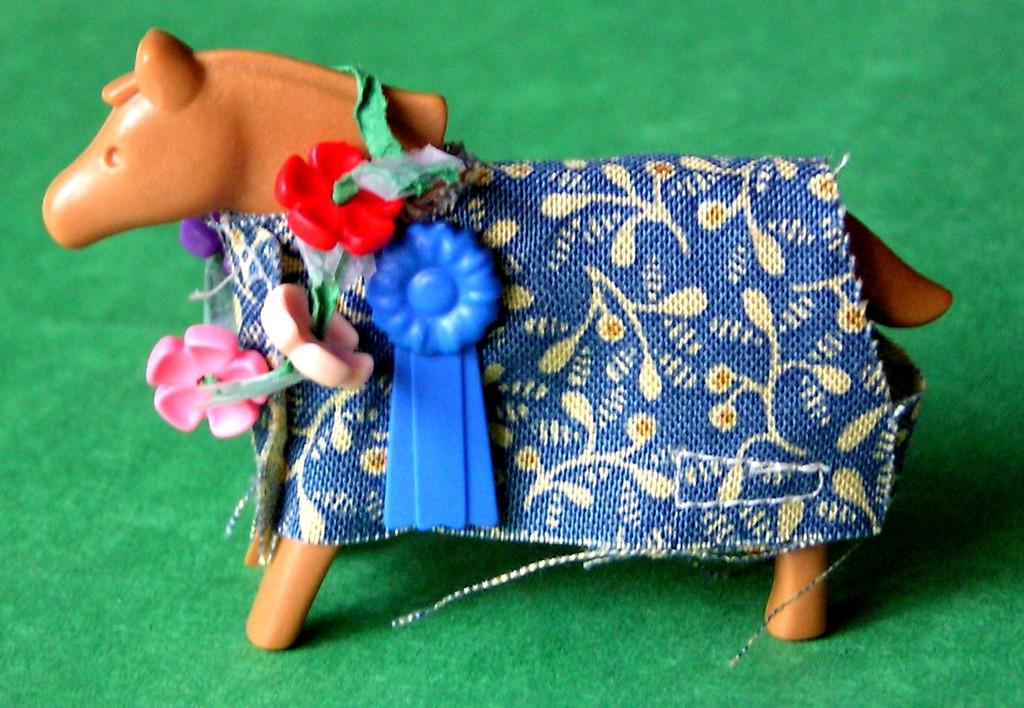What type of toy is present in the image? There is a toy horse in the image. How is the toy horse decorated? The toy horse is decorated with a cloth and other items. What is the color or material of the surface in the image? The image appears to be on a green carpet or surface. How many cakes does the laborer decide to bake in the image? There are no cakes or laborers present in the image. 